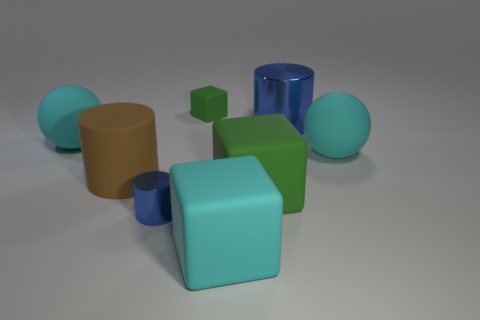Subtract all green rubber cubes. How many cubes are left? 1 Subtract all blue cylinders. How many cylinders are left? 1 Subtract all cylinders. How many objects are left? 5 Subtract 1 spheres. How many spheres are left? 1 Add 1 brown cylinders. How many objects exist? 9 Subtract all red blocks. How many red spheres are left? 0 Subtract all brown cylinders. Subtract all large cyan matte blocks. How many objects are left? 6 Add 2 large things. How many large things are left? 8 Add 8 large yellow matte cylinders. How many large yellow matte cylinders exist? 8 Subtract 0 gray spheres. How many objects are left? 8 